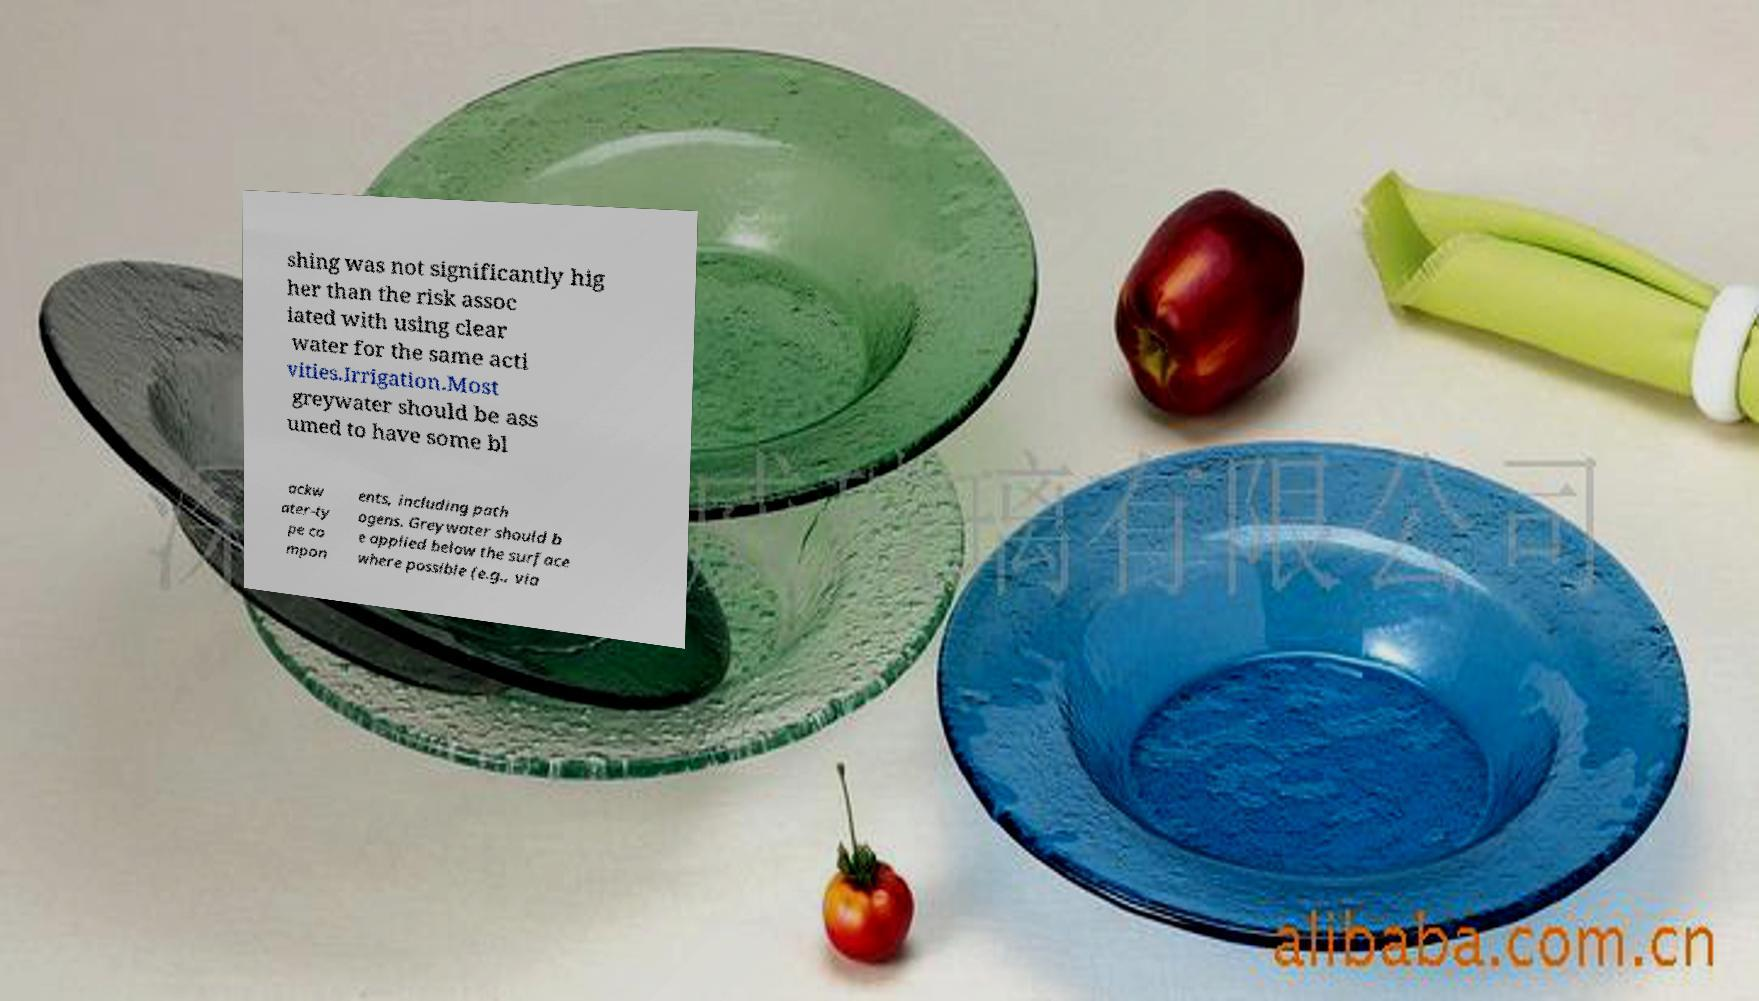Could you extract and type out the text from this image? shing was not significantly hig her than the risk assoc iated with using clear water for the same acti vities.Irrigation.Most greywater should be ass umed to have some bl ackw ater-ty pe co mpon ents, including path ogens. Greywater should b e applied below the surface where possible (e.g., via 